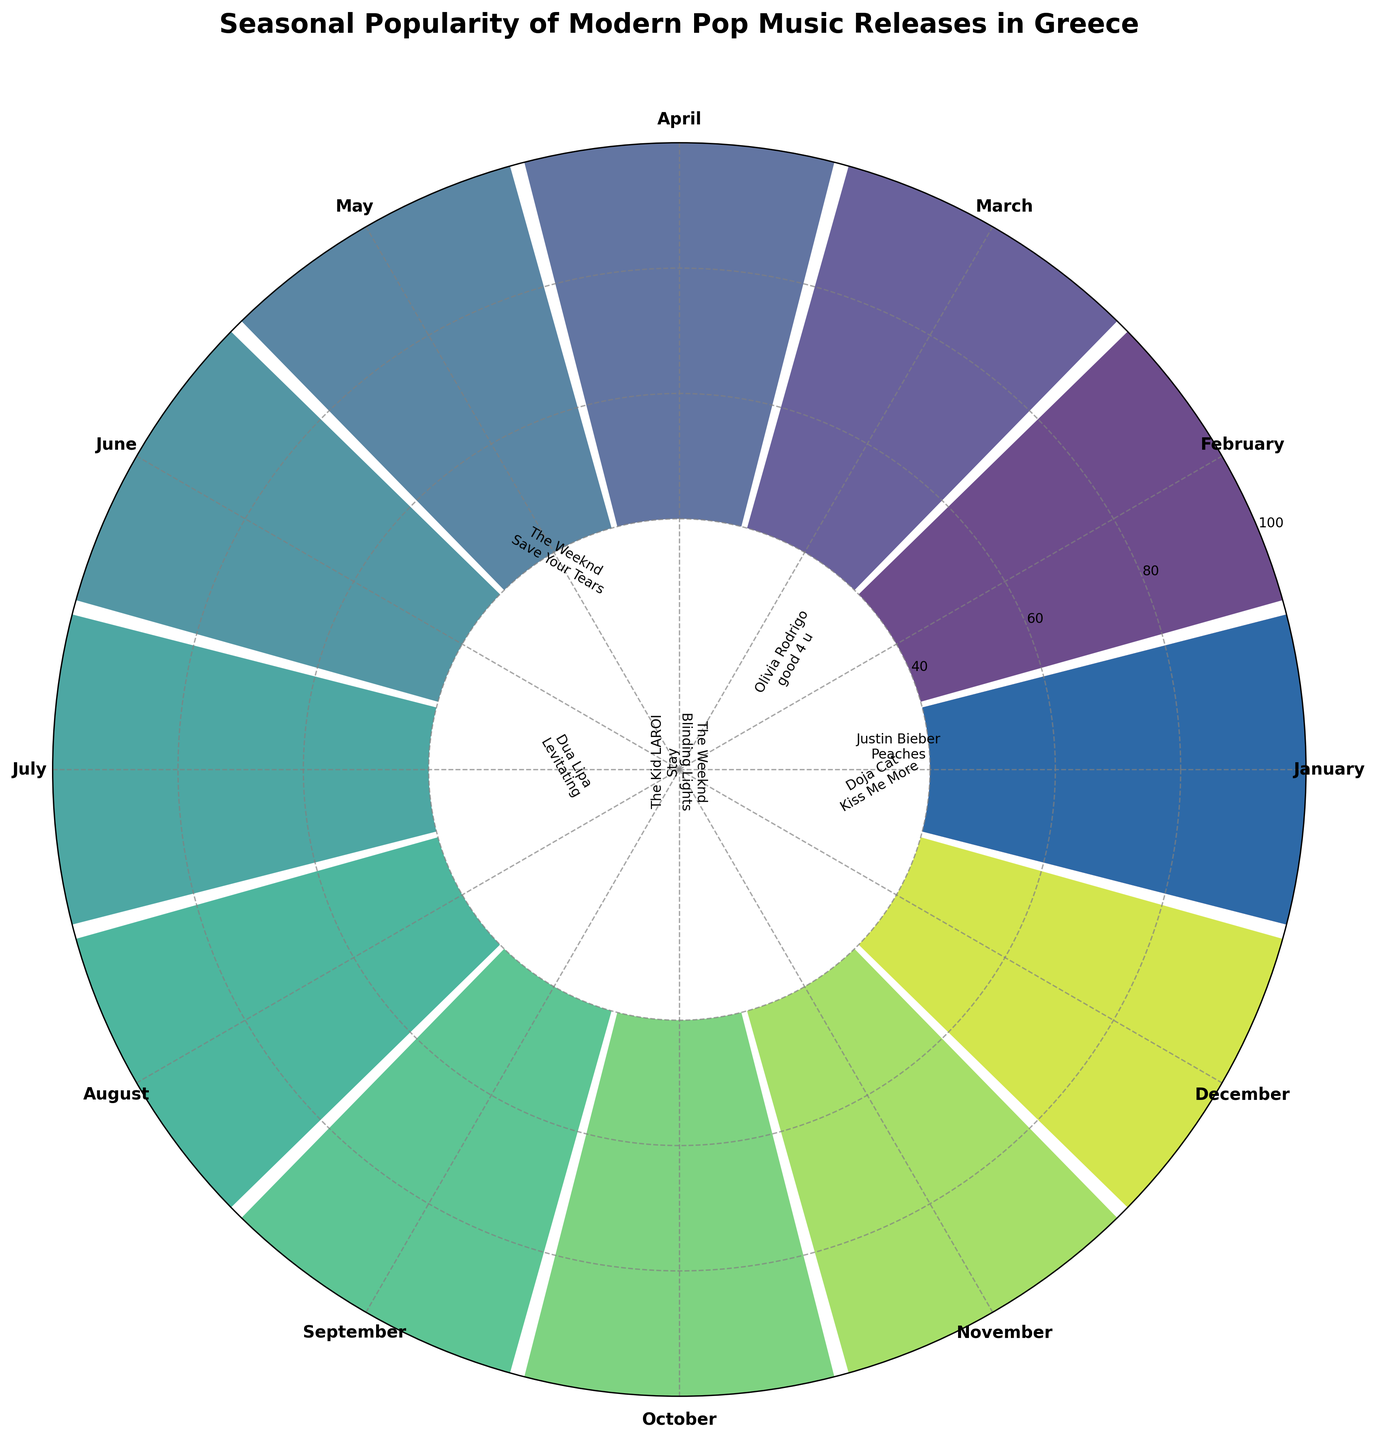What's the title of the figure? The title is prominently displayed at the top of the figure, indicating the main subject of the visualization.
Answer: Seasonal Popularity of Modern Pop Music Releases in Greece How many months are represented in the chart? Each segment of the rose chart represents one month, with a total of 12 segments representing the 12 months of the year.
Answer: 12 Which song had the highest popularity score, and in which month was it released? The highest bar in the chart will identify the month and song with the highest popularity score, and the annotation at the bar's tip will give details about the artist and song.
Answer: All I Want for Christmas Is You in December What is the average popularity score of the songs released from January to June? To find the average, sum the popularity scores from January to June and divide by the number of months, (75+70+72+65+68+80)/6.
Answer: 71.67 How do the popularity scores in the summer months (June, July, August) compare to the scores in the winter months (December, January, February)? Compare the popularity scores of the summer months (80, 73, 66) with the winter months (85, 75, 70).
Answer: Summer months generally have lower scores compared to winter months Which month has the lowest popularity score, and what is the score? Identify the shortest bar in the chart and read the corresponding popularity score and month from the annotations.
Answer: April with a score of 65 Are there any artists who have more than one song in the chart? By examining the annotations around the chart, look for repeating artist names to identify if any artists have multiple songs featured.
Answer: The Weeknd with Blinding Lights and Save Your Tears What is the range of the popularity scores in the figure? Determine the highest and lowest scores from the chart and subtract the lowest from the highest score, i.e., 85 (highest) - 65 (lowest).
Answer: 20 Which season appears to have the most consistently high popularity scores? Assess the scores by season and determine which season has popularity scores that are relatively high and consistent.
Answer: Winter (December, January, February) How does the popularity score of "Easy On Me" by Adele compare to the average popularity score for the year? Calculate the average score for the year by summing all the scores and dividing by 12. Compare this value with the score for "Easy On Me."
Answer: Easy On Me (78) is higher than the average (72.17) 